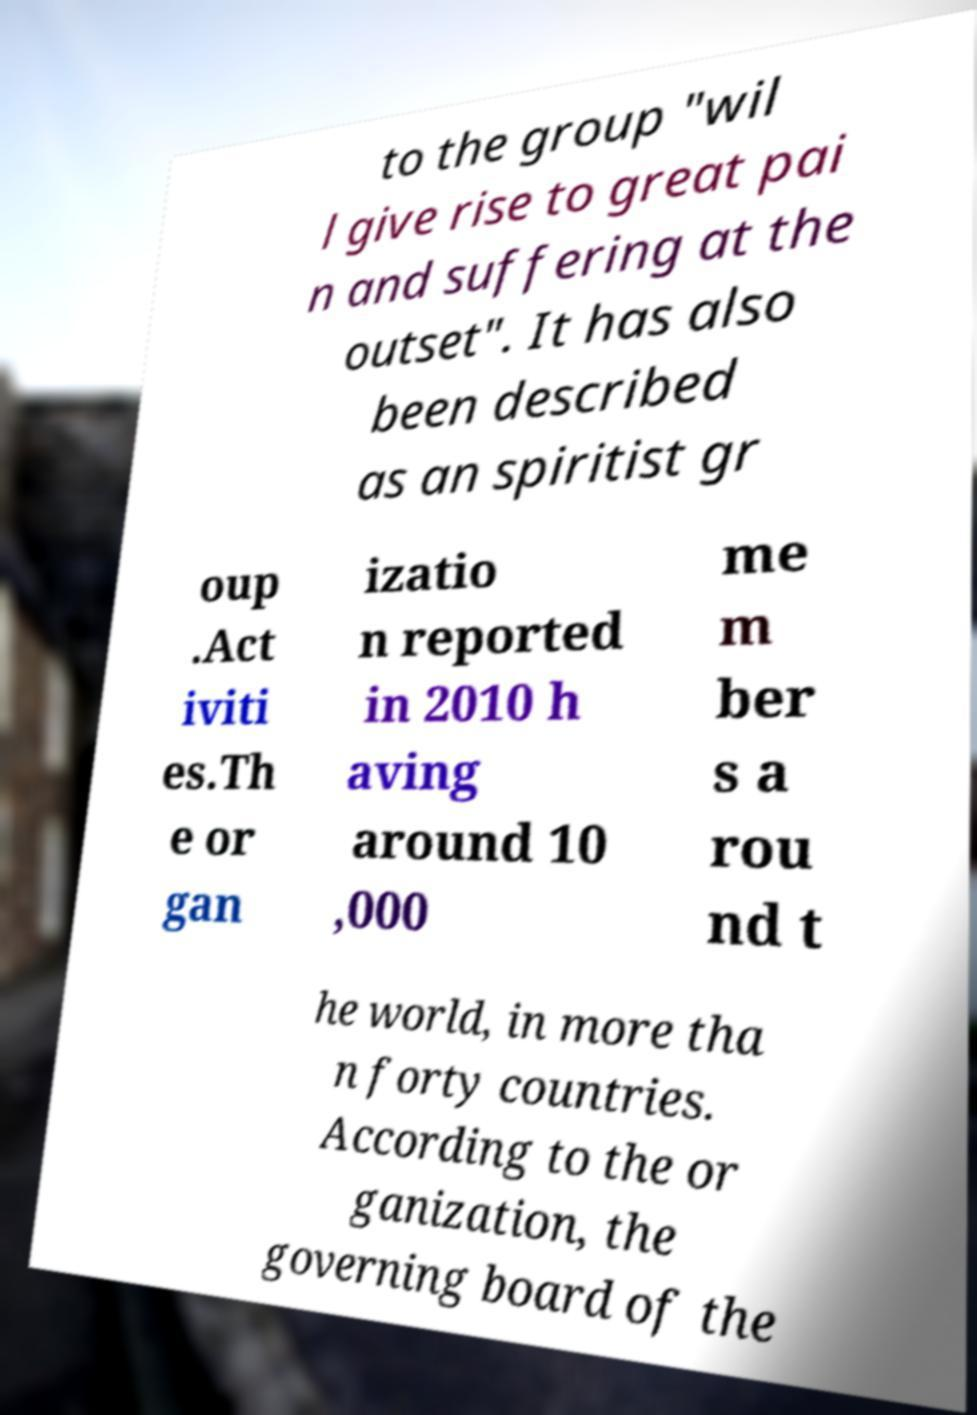For documentation purposes, I need the text within this image transcribed. Could you provide that? to the group "wil l give rise to great pai n and suffering at the outset". It has also been described as an spiritist gr oup .Act iviti es.Th e or gan izatio n reported in 2010 h aving around 10 ,000 me m ber s a rou nd t he world, in more tha n forty countries. According to the or ganization, the governing board of the 